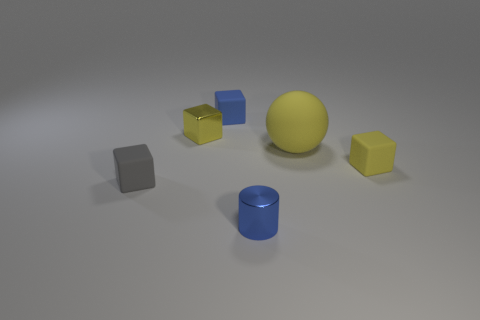Subtract 1 blocks. How many blocks are left? 3 Subtract all metal cubes. How many cubes are left? 3 Subtract all blue cubes. How many cubes are left? 3 Subtract all cyan blocks. Subtract all red balls. How many blocks are left? 4 Add 2 green matte cylinders. How many objects exist? 8 Subtract all blocks. How many objects are left? 2 Add 5 large gray metal things. How many large gray metal things exist? 5 Subtract 1 blue blocks. How many objects are left? 5 Subtract all yellow rubber objects. Subtract all purple matte spheres. How many objects are left? 4 Add 5 tiny metal cubes. How many tiny metal cubes are left? 6 